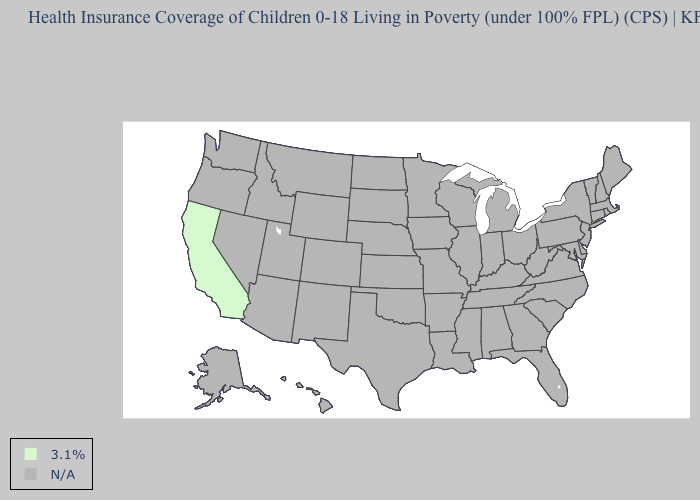Name the states that have a value in the range N/A?
Quick response, please. Alabama, Alaska, Arizona, Arkansas, Colorado, Connecticut, Delaware, Florida, Georgia, Hawaii, Idaho, Illinois, Indiana, Iowa, Kansas, Kentucky, Louisiana, Maine, Maryland, Massachusetts, Michigan, Minnesota, Mississippi, Missouri, Montana, Nebraska, Nevada, New Hampshire, New Jersey, New Mexico, New York, North Carolina, North Dakota, Ohio, Oklahoma, Oregon, Pennsylvania, Rhode Island, South Carolina, South Dakota, Tennessee, Texas, Utah, Vermont, Virginia, Washington, West Virginia, Wisconsin, Wyoming. Name the states that have a value in the range 3.1%?
Give a very brief answer. California. Name the states that have a value in the range N/A?
Concise answer only. Alabama, Alaska, Arizona, Arkansas, Colorado, Connecticut, Delaware, Florida, Georgia, Hawaii, Idaho, Illinois, Indiana, Iowa, Kansas, Kentucky, Louisiana, Maine, Maryland, Massachusetts, Michigan, Minnesota, Mississippi, Missouri, Montana, Nebraska, Nevada, New Hampshire, New Jersey, New Mexico, New York, North Carolina, North Dakota, Ohio, Oklahoma, Oregon, Pennsylvania, Rhode Island, South Carolina, South Dakota, Tennessee, Texas, Utah, Vermont, Virginia, Washington, West Virginia, Wisconsin, Wyoming. Does the first symbol in the legend represent the smallest category?
Concise answer only. Yes. What is the value of Florida?
Give a very brief answer. N/A. What is the value of Florida?
Concise answer only. N/A. What is the value of Ohio?
Give a very brief answer. N/A. Is the legend a continuous bar?
Write a very short answer. No. Name the states that have a value in the range N/A?
Concise answer only. Alabama, Alaska, Arizona, Arkansas, Colorado, Connecticut, Delaware, Florida, Georgia, Hawaii, Idaho, Illinois, Indiana, Iowa, Kansas, Kentucky, Louisiana, Maine, Maryland, Massachusetts, Michigan, Minnesota, Mississippi, Missouri, Montana, Nebraska, Nevada, New Hampshire, New Jersey, New Mexico, New York, North Carolina, North Dakota, Ohio, Oklahoma, Oregon, Pennsylvania, Rhode Island, South Carolina, South Dakota, Tennessee, Texas, Utah, Vermont, Virginia, Washington, West Virginia, Wisconsin, Wyoming. What is the value of Tennessee?
Be succinct. N/A. What is the value of Nebraska?
Answer briefly. N/A. 